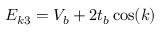<formula> <loc_0><loc_0><loc_500><loc_500>E _ { k 3 } = V _ { b } + 2 t _ { b } \cos ( k )</formula> 